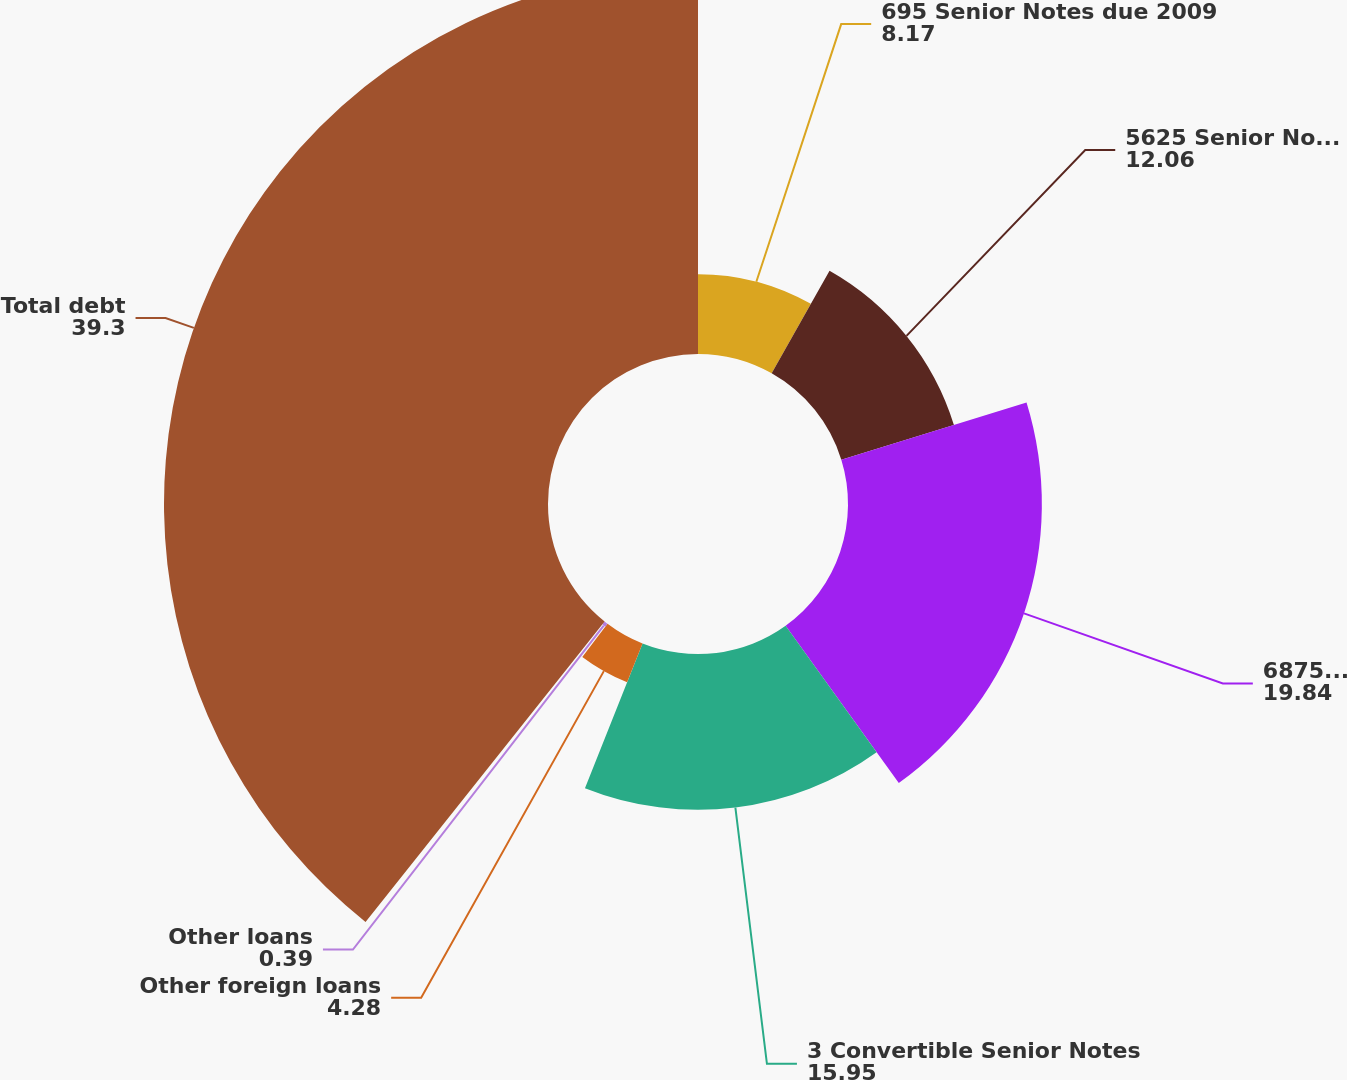<chart> <loc_0><loc_0><loc_500><loc_500><pie_chart><fcel>695 Senior Notes due 2009<fcel>5625 Senior Notes due 2013<fcel>6875 Senior Notes due 2033<fcel>3 Convertible Senior Notes<fcel>Other foreign loans<fcel>Other loans<fcel>Total debt<nl><fcel>8.17%<fcel>12.06%<fcel>19.84%<fcel>15.95%<fcel>4.28%<fcel>0.39%<fcel>39.3%<nl></chart> 